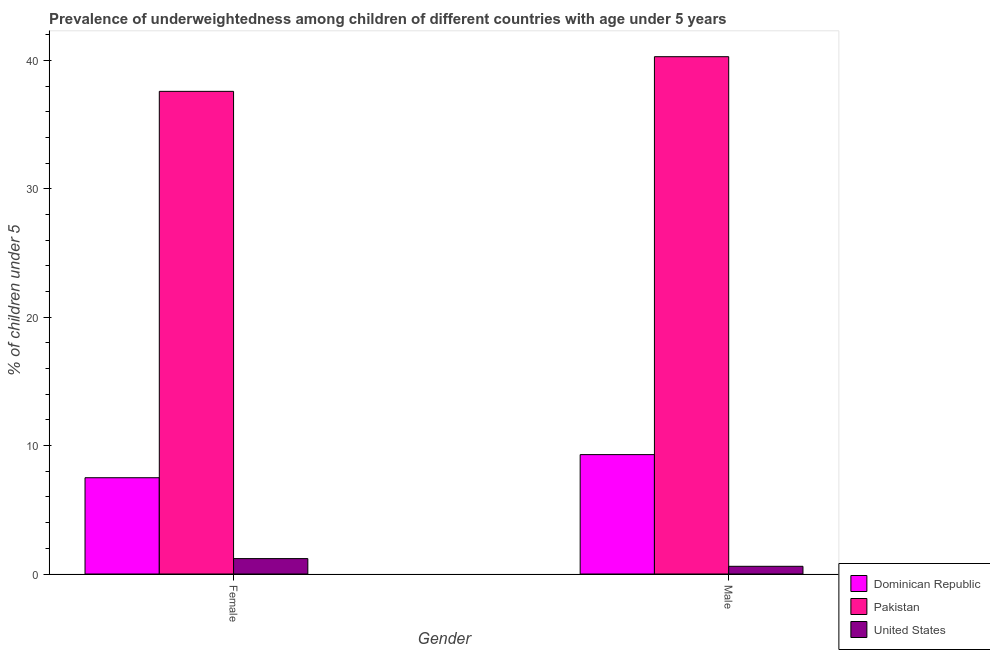Are the number of bars on each tick of the X-axis equal?
Provide a succinct answer. Yes. How many bars are there on the 1st tick from the right?
Your response must be concise. 3. What is the percentage of underweighted male children in Dominican Republic?
Ensure brevity in your answer.  9.3. Across all countries, what is the maximum percentage of underweighted male children?
Offer a very short reply. 40.3. Across all countries, what is the minimum percentage of underweighted female children?
Offer a terse response. 1.2. In which country was the percentage of underweighted female children maximum?
Ensure brevity in your answer.  Pakistan. In which country was the percentage of underweighted male children minimum?
Provide a short and direct response. United States. What is the total percentage of underweighted male children in the graph?
Make the answer very short. 50.2. What is the difference between the percentage of underweighted male children in Pakistan and that in Dominican Republic?
Offer a very short reply. 31. What is the difference between the percentage of underweighted male children in United States and the percentage of underweighted female children in Dominican Republic?
Offer a very short reply. -6.9. What is the average percentage of underweighted male children per country?
Offer a terse response. 16.73. What is the difference between the percentage of underweighted female children and percentage of underweighted male children in Dominican Republic?
Make the answer very short. -1.8. What is the ratio of the percentage of underweighted male children in Dominican Republic to that in Pakistan?
Provide a succinct answer. 0.23. Is the percentage of underweighted female children in United States less than that in Pakistan?
Offer a very short reply. Yes. What does the 3rd bar from the right in Female represents?
Ensure brevity in your answer.  Dominican Republic. How many bars are there?
Ensure brevity in your answer.  6. How many countries are there in the graph?
Keep it short and to the point. 3. Does the graph contain grids?
Make the answer very short. No. Where does the legend appear in the graph?
Your answer should be very brief. Bottom right. How are the legend labels stacked?
Your answer should be compact. Vertical. What is the title of the graph?
Make the answer very short. Prevalence of underweightedness among children of different countries with age under 5 years. Does "Sub-Saharan Africa (all income levels)" appear as one of the legend labels in the graph?
Give a very brief answer. No. What is the label or title of the X-axis?
Give a very brief answer. Gender. What is the label or title of the Y-axis?
Provide a short and direct response.  % of children under 5. What is the  % of children under 5 of Pakistan in Female?
Your response must be concise. 37.6. What is the  % of children under 5 of United States in Female?
Your answer should be compact. 1.2. What is the  % of children under 5 of Dominican Republic in Male?
Your answer should be very brief. 9.3. What is the  % of children under 5 in Pakistan in Male?
Your answer should be compact. 40.3. What is the  % of children under 5 in United States in Male?
Provide a short and direct response. 0.6. Across all Gender, what is the maximum  % of children under 5 of Dominican Republic?
Provide a succinct answer. 9.3. Across all Gender, what is the maximum  % of children under 5 in Pakistan?
Give a very brief answer. 40.3. Across all Gender, what is the maximum  % of children under 5 in United States?
Ensure brevity in your answer.  1.2. Across all Gender, what is the minimum  % of children under 5 of Dominican Republic?
Your response must be concise. 7.5. Across all Gender, what is the minimum  % of children under 5 of Pakistan?
Your answer should be compact. 37.6. Across all Gender, what is the minimum  % of children under 5 in United States?
Offer a very short reply. 0.6. What is the total  % of children under 5 in Dominican Republic in the graph?
Your answer should be compact. 16.8. What is the total  % of children under 5 of Pakistan in the graph?
Make the answer very short. 77.9. What is the total  % of children under 5 of United States in the graph?
Provide a succinct answer. 1.8. What is the difference between the  % of children under 5 in Dominican Republic in Female and that in Male?
Provide a short and direct response. -1.8. What is the difference between the  % of children under 5 in United States in Female and that in Male?
Offer a terse response. 0.6. What is the difference between the  % of children under 5 in Dominican Republic in Female and the  % of children under 5 in Pakistan in Male?
Offer a terse response. -32.8. What is the difference between the  % of children under 5 of Pakistan in Female and the  % of children under 5 of United States in Male?
Your answer should be very brief. 37. What is the average  % of children under 5 of Pakistan per Gender?
Offer a terse response. 38.95. What is the difference between the  % of children under 5 in Dominican Republic and  % of children under 5 in Pakistan in Female?
Provide a succinct answer. -30.1. What is the difference between the  % of children under 5 in Dominican Republic and  % of children under 5 in United States in Female?
Offer a very short reply. 6.3. What is the difference between the  % of children under 5 in Pakistan and  % of children under 5 in United States in Female?
Provide a succinct answer. 36.4. What is the difference between the  % of children under 5 of Dominican Republic and  % of children under 5 of Pakistan in Male?
Your response must be concise. -31. What is the difference between the  % of children under 5 in Dominican Republic and  % of children under 5 in United States in Male?
Make the answer very short. 8.7. What is the difference between the  % of children under 5 in Pakistan and  % of children under 5 in United States in Male?
Provide a succinct answer. 39.7. What is the ratio of the  % of children under 5 in Dominican Republic in Female to that in Male?
Provide a short and direct response. 0.81. What is the ratio of the  % of children under 5 of Pakistan in Female to that in Male?
Offer a very short reply. 0.93. What is the ratio of the  % of children under 5 of United States in Female to that in Male?
Offer a very short reply. 2. What is the difference between the highest and the second highest  % of children under 5 in Dominican Republic?
Offer a very short reply. 1.8. What is the difference between the highest and the second highest  % of children under 5 in Pakistan?
Your answer should be compact. 2.7. What is the difference between the highest and the lowest  % of children under 5 in Pakistan?
Provide a succinct answer. 2.7. What is the difference between the highest and the lowest  % of children under 5 in United States?
Your response must be concise. 0.6. 